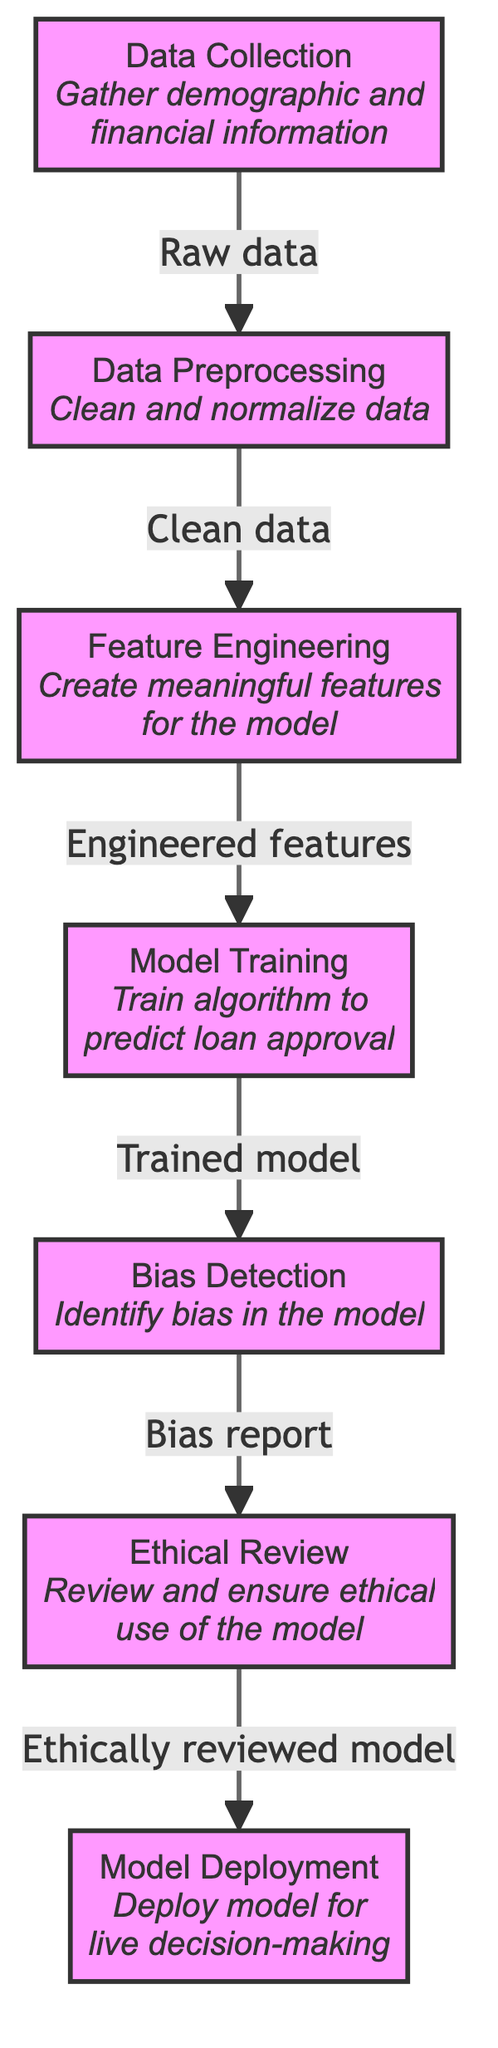What is the first step in the diagram? The first step in the diagram is labeled as "Data Collection," indicating it is the initial process where demographic and financial information is gathered.
Answer: Data Collection How many nodes are present in the diagram? The diagram consists of seven nodes, which represent various steps involved in the bias detection process of loan approval algorithms.
Answer: Seven What does the "bias_detection" node produce? The "bias_detection" node produces a "Bias report," which is essential for identifying bias present in the loan approval model.
Answer: Bias report What comes after "model_training"? After "model_training," the next step is "bias_detection," indicating that the trained model undergoes a bias detection process.
Answer: Bias Detection What is the relationship between "bias_detection" and "ethical_review"? The relationship is that "bias_detection" outputs a bias report, which is then reviewed in the "ethical_review" phase to ensure ethical use of the model.
Answer: Outputs a bias report Why is "ethical_review" necessary in this process? "Ethical_review" is necessary to review and ensure the ethical use of the model, addressing potential biases identified in prior steps to uphold moral standards.
Answer: Review and ensure ethical use Which node leads to "deployment"? The node that leads to "deployment" is "ethical_review," signifying that the model must be ethically reviewed before being deployed for live decision-making.
Answer: Ethical Review What does "data_preprocessing" focus on? "Data_preprocessing" focuses on cleaning and normalizing the data collected during the initial data collection phase, ensuring it is suitable for further processing.
Answer: Clean and normalize data 